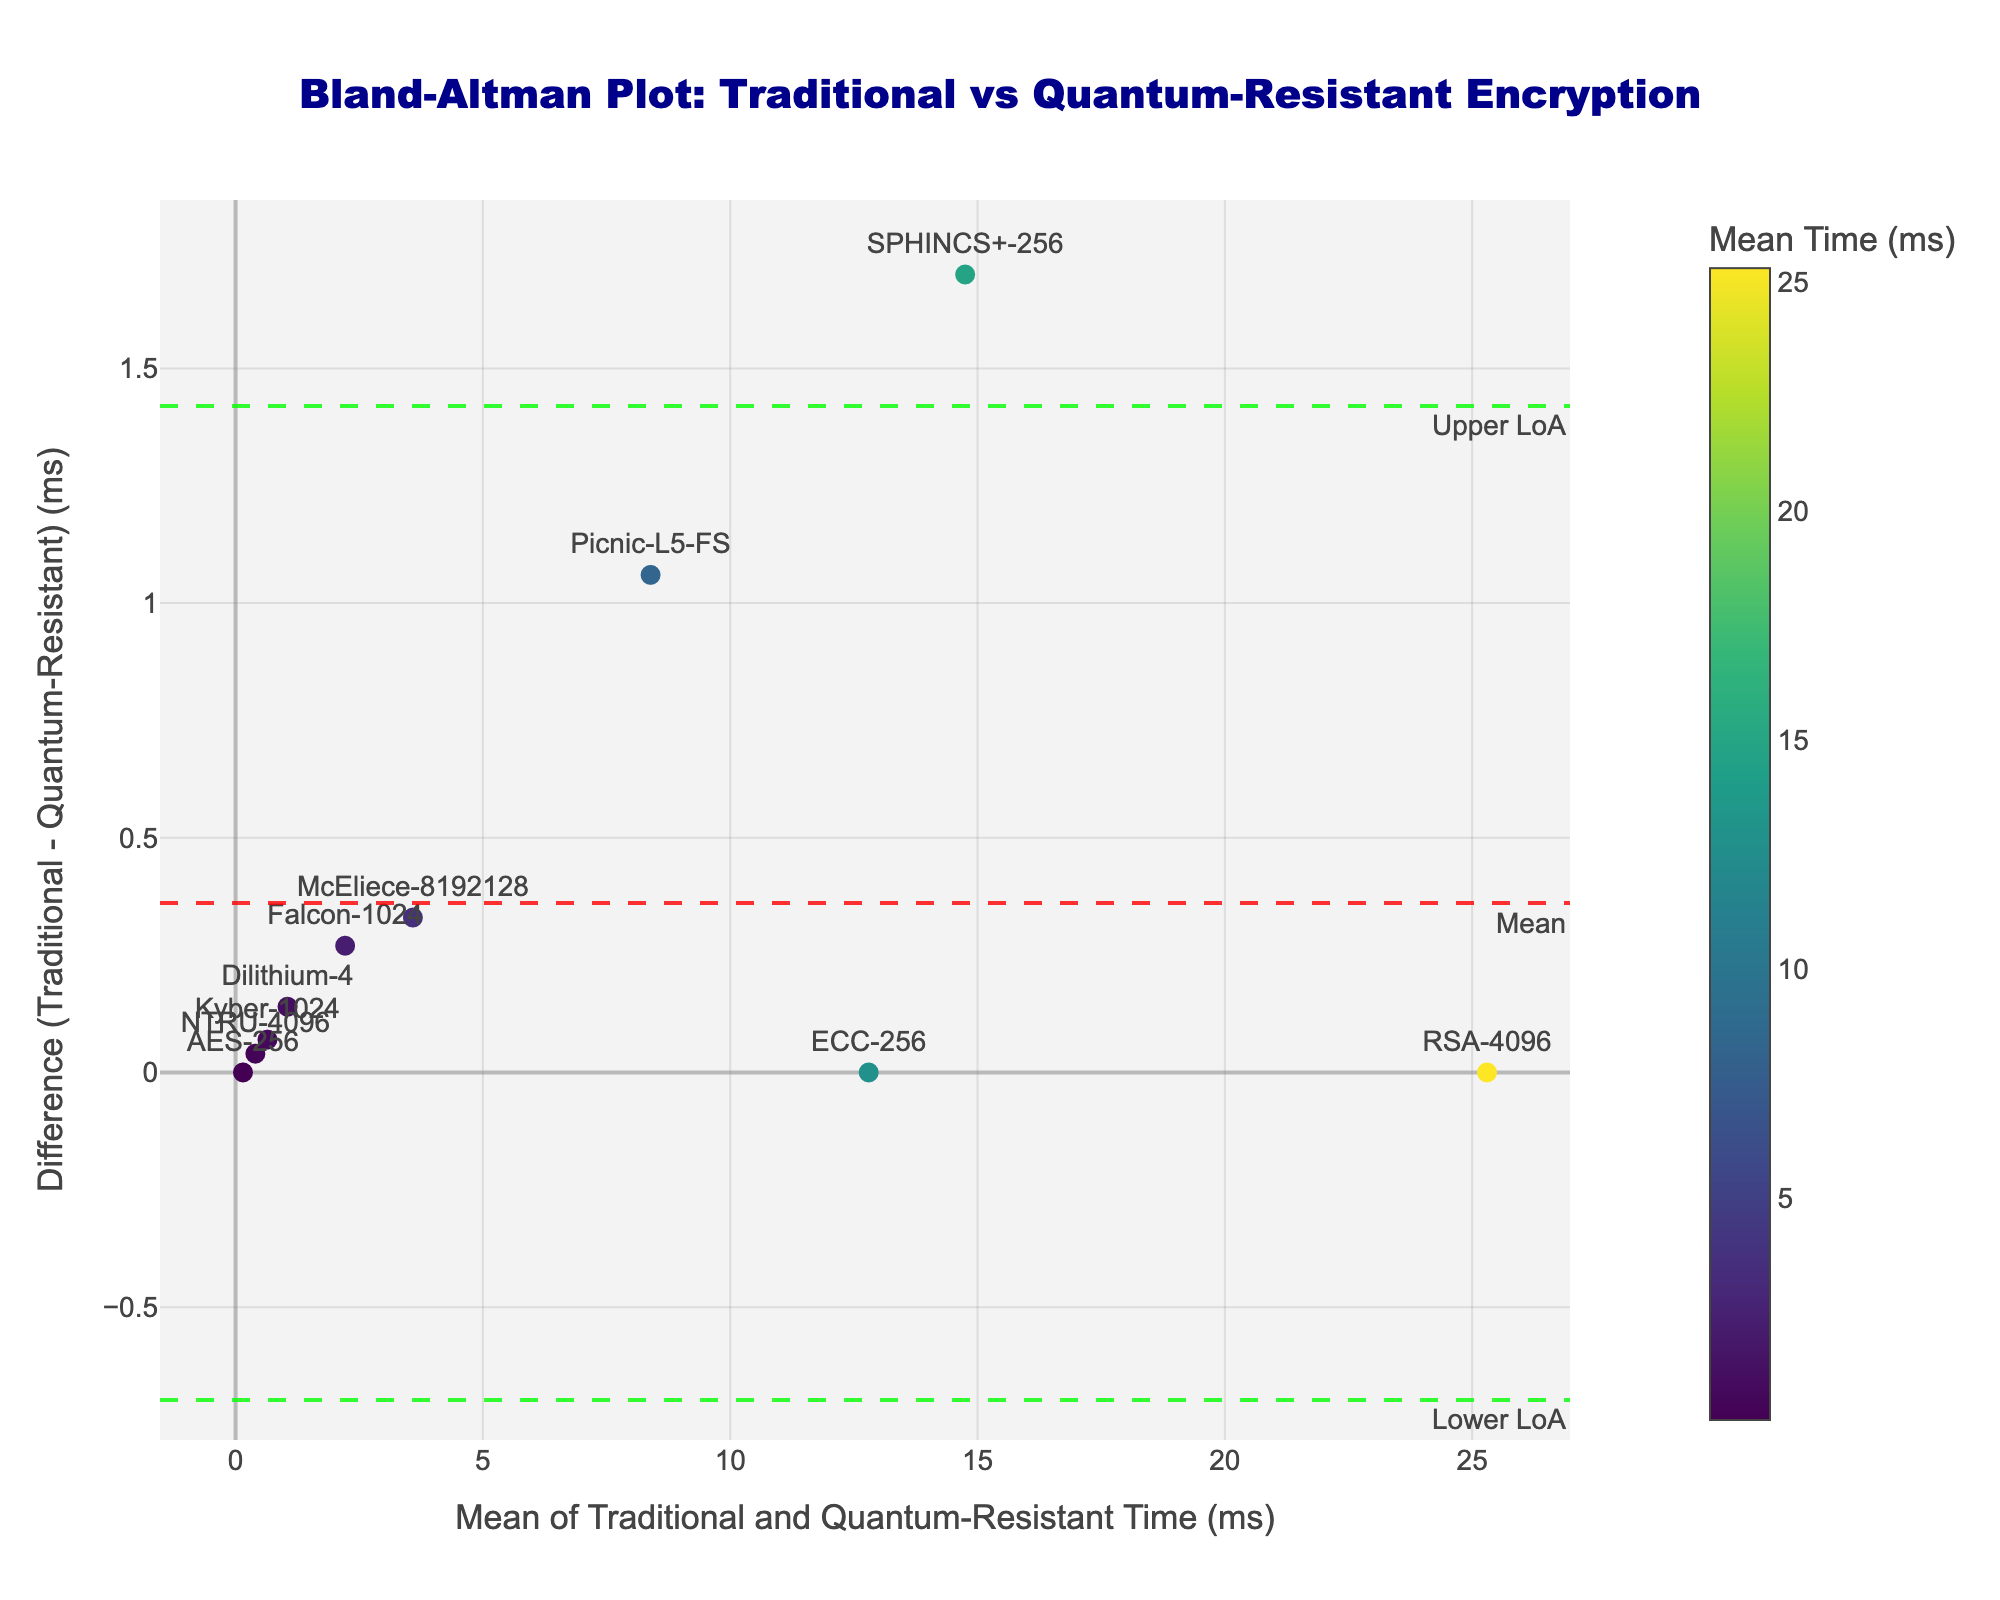What does the title of the plot indicate? The title provides an overview of the figure. It clearly indicates that the plot is a Bland-Altman plot designed to compare the performance of traditional vs quantum-resistant encryption algorithms. The comparison is based on the execution time in milliseconds.
Answer: Bland-Altman Plot: Traditional vs Quantum-Resistant Encryption What do the axes represent in the Bland-Altman plot? The x-axis represents the mean of traditional and quantum-resistant encryption times in milliseconds, and the y-axis represents the difference between the traditional and quantum-resistant times in milliseconds. Mean differences and limits of agreement (LoA) can be used to evaluate the consistency between the two methods.
Answer: X-axis: Mean of Traditional and Quantum-Resistant Time (ms); Y-axis: Difference (Traditional - Quantum-Resistant) (ms) How many encryption methods are compared in the plot? By looking at the number of unique data points (each labeled with a method) in the scatter plot, we can determine that there are ten encryption methods being compared.
Answer: 10 Which encryption method shows the largest difference in encryption times between traditional and quantum-resistant methods? By observing the largest distance from the 0 baseline on the y-axis, we can determine that the method 'SPHINCS+-256' exhibits the largest negative difference, indicating the largest reduction in encryption time when switching from traditional to quantum-resistant methods.
Answer: SPHINCS+-256 What do the horizontal dashed lines represent in the plot? The horizontal dashed lines in the plot represent key statistical measures: the red line indicates the mean difference between traditional and quantum-resistant times, while the green lines show the upper and lower limits of agreement (LoA). These lines help in assessing the agreement between the two methods.
Answer: Mean difference and limits of agreement (LoA) What is the mean difference in encryption time between traditional and quantum-resistant methods? The mean difference is given by the red horizontal dashed line, which is labeled as 'Mean' and positioned at approximately 0.69 milliseconds. This line shows the average difference between the traditional and quantum-resistant times across all methods.
Answer: 0.69 ms Which two methods have the closest mean encryption time? By observing the values near the majority of points along the x-axis (mean encryption time), we see that 'AES-256' and 'ECC-256' cluster closely around the same mean value indicating they have nearly identical times between traditional and quantum-resistant methods.
Answer: AES-256 and ECC-256 What is the range for the Limits of Agreement (LoA)? To determine the range for the Limits of Agreement, we look at the positioning of the green dashed lines. The plot shows these lines, labeled 'Upper LoA' and 'Lower LoA,' at the upper and lower extremes of the discrepancy between the two methods, in this case approximately 7.92 ms and -6.53 ms respectively.
Answer: -6.53 ms to 7.92 ms Which encryption method has the smallest difference in execution time? Observing the data points near the 0 line on the y-axis helps us identify that 'RSA-4096' has a difference closely approaching zero, indicating that its traditional and quantum-resistant times are nearly equal.
Answer: RSA-4096 How many data points fall outside the Limits of Agreement (LoA)? By counting the number of points that lie outside the green dashed lines (LoA) in the plot, we observe that none of the data points fall outside these limits, indicating a good agreement between traditional and quantum-resistant methods within the calculated LoA.
Answer: 0 